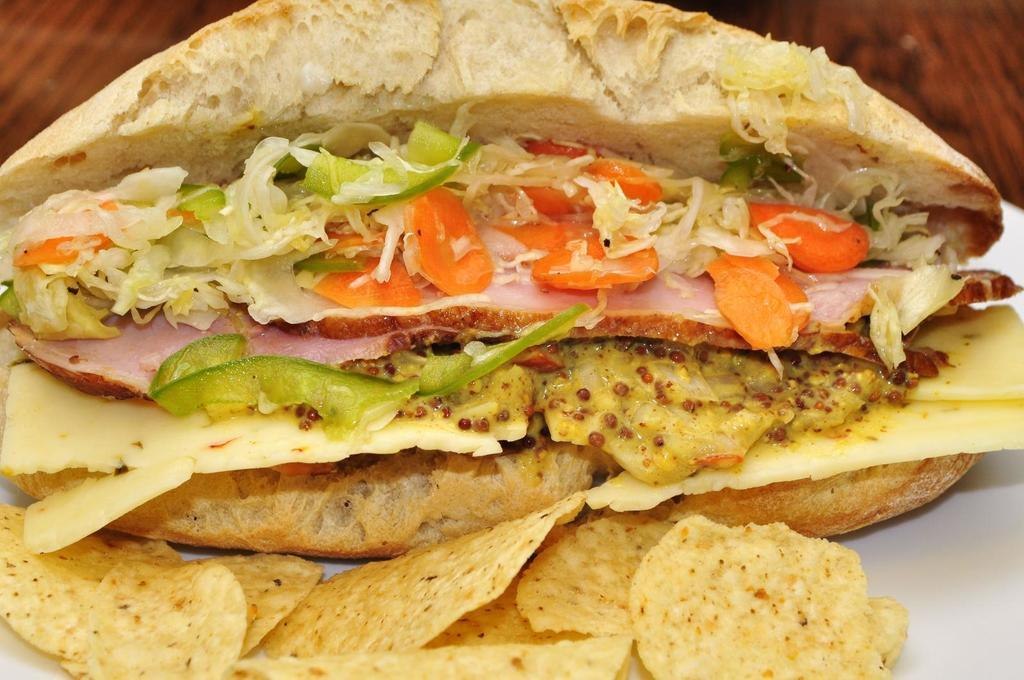What is placed on the white platform in the image? There is food on a white platform in the image. Can you describe the background of the image? There is a wooden surface visible in the background of the image. Reasoning: Let's think step by identifying the main subjects and objects in the image based on the provided facts. We then formulate questions that focus on the location and characteristics of these subjects and objects, ensuring that each question can be answered definitively with the information given. We avoid yes/no questions and ensure that the language is simple and clear. Absurd Question/Answer: How many cars are parked on the wooden surface in the image? There are no cars present in the image; it features a wooden surface in the background. What type of love is being expressed in the image? There is no expression of love present in the image; it features food on a white platform and a wooden surface in the background. How much sugar is in the food on the white platform in the image? There is no information about the sugar content in the food on the white platform in the image. Additionally, the image does not contain any sugar. 